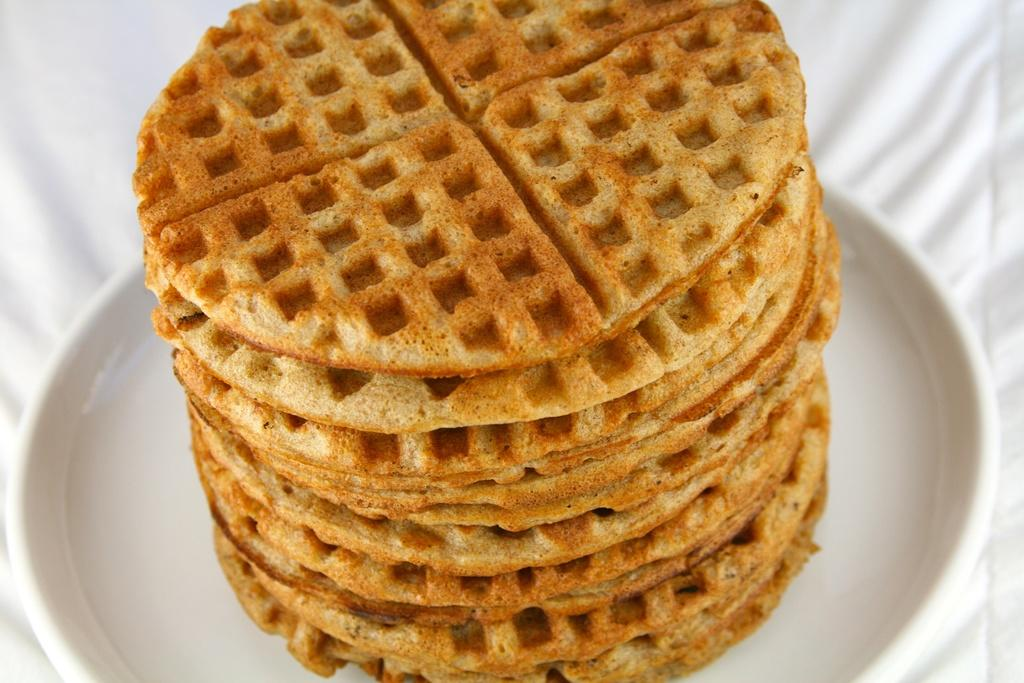What type of food can be seen in the image? There are cookies in the image. What is the color of the plate on which the cookies are placed? The cookies are on a white color plate. What type of bomb is visible in the image? There is no bomb present in the image; it features cookies on a white plate. Can you see any veins in the cookies? Cookies do not have veins, as they are not living organisms. 